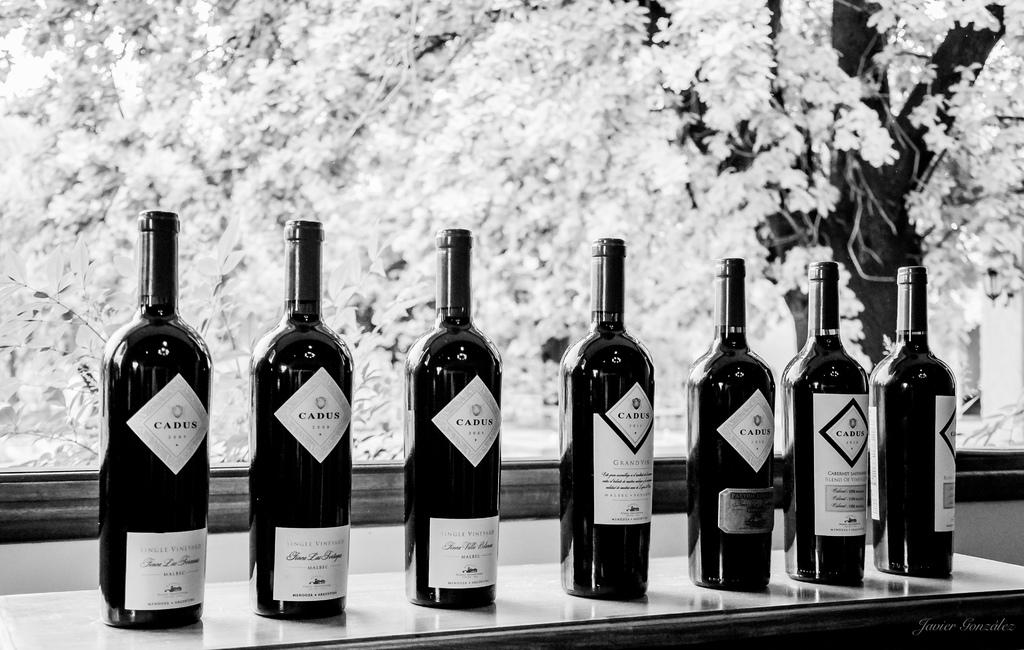<image>
Describe the image concisely. Seven bottles of win by Cadus winery, some are Malbecs 